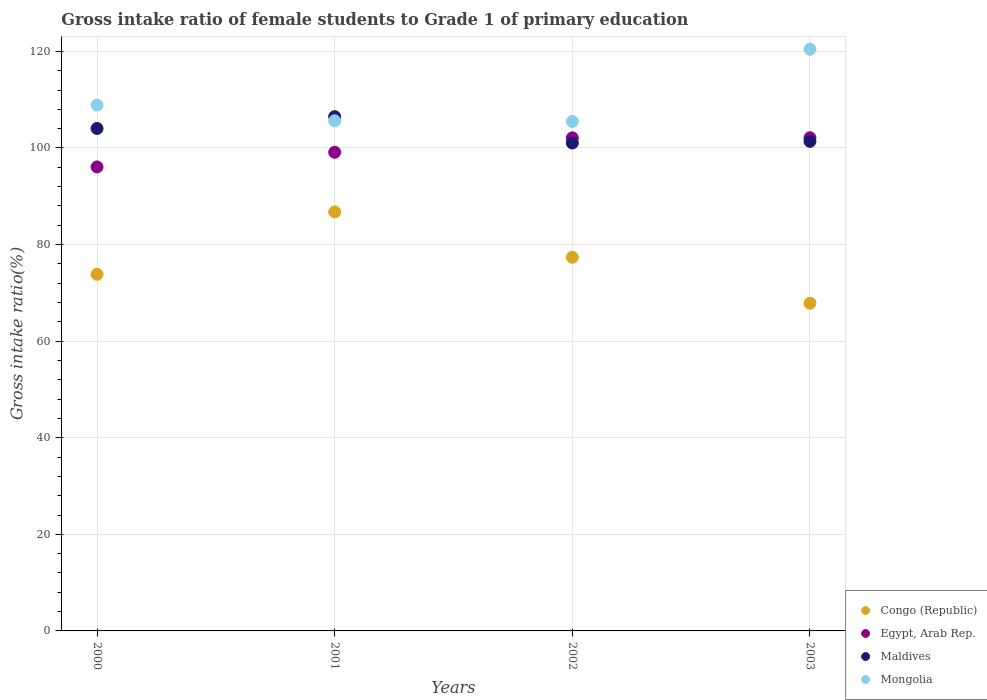How many different coloured dotlines are there?
Your response must be concise. 4. What is the gross intake ratio in Congo (Republic) in 2002?
Your response must be concise. 77.37. Across all years, what is the maximum gross intake ratio in Congo (Republic)?
Offer a terse response. 86.76. Across all years, what is the minimum gross intake ratio in Maldives?
Provide a succinct answer. 101.03. In which year was the gross intake ratio in Egypt, Arab Rep. maximum?
Your answer should be compact. 2003. What is the total gross intake ratio in Maldives in the graph?
Offer a very short reply. 412.91. What is the difference between the gross intake ratio in Maldives in 2001 and that in 2003?
Offer a terse response. 5.12. What is the difference between the gross intake ratio in Mongolia in 2002 and the gross intake ratio in Egypt, Arab Rep. in 2000?
Make the answer very short. 9.41. What is the average gross intake ratio in Congo (Republic) per year?
Make the answer very short. 76.45. In the year 2003, what is the difference between the gross intake ratio in Maldives and gross intake ratio in Mongolia?
Give a very brief answer. -19.07. What is the ratio of the gross intake ratio in Egypt, Arab Rep. in 2000 to that in 2003?
Your answer should be compact. 0.94. Is the difference between the gross intake ratio in Maldives in 2001 and 2002 greater than the difference between the gross intake ratio in Mongolia in 2001 and 2002?
Give a very brief answer. Yes. What is the difference between the highest and the second highest gross intake ratio in Mongolia?
Offer a very short reply. 11.55. What is the difference between the highest and the lowest gross intake ratio in Mongolia?
Offer a very short reply. 14.95. Is it the case that in every year, the sum of the gross intake ratio in Mongolia and gross intake ratio in Maldives  is greater than the gross intake ratio in Congo (Republic)?
Keep it short and to the point. Yes. Is the gross intake ratio in Mongolia strictly greater than the gross intake ratio in Congo (Republic) over the years?
Your answer should be compact. Yes. How many dotlines are there?
Your response must be concise. 4. What is the difference between two consecutive major ticks on the Y-axis?
Offer a terse response. 20. Does the graph contain any zero values?
Ensure brevity in your answer.  No. How are the legend labels stacked?
Make the answer very short. Vertical. What is the title of the graph?
Your response must be concise. Gross intake ratio of female students to Grade 1 of primary education. Does "St. Kitts and Nevis" appear as one of the legend labels in the graph?
Offer a terse response. No. What is the label or title of the X-axis?
Offer a very short reply. Years. What is the label or title of the Y-axis?
Offer a very short reply. Gross intake ratio(%). What is the Gross intake ratio(%) of Congo (Republic) in 2000?
Give a very brief answer. 73.83. What is the Gross intake ratio(%) in Egypt, Arab Rep. in 2000?
Provide a succinct answer. 96.07. What is the Gross intake ratio(%) of Maldives in 2000?
Your response must be concise. 104.04. What is the Gross intake ratio(%) in Mongolia in 2000?
Offer a terse response. 108.89. What is the Gross intake ratio(%) in Congo (Republic) in 2001?
Your answer should be compact. 86.76. What is the Gross intake ratio(%) in Egypt, Arab Rep. in 2001?
Provide a short and direct response. 99.11. What is the Gross intake ratio(%) in Maldives in 2001?
Your answer should be very brief. 106.48. What is the Gross intake ratio(%) of Mongolia in 2001?
Provide a succinct answer. 105.63. What is the Gross intake ratio(%) in Congo (Republic) in 2002?
Provide a succinct answer. 77.37. What is the Gross intake ratio(%) of Egypt, Arab Rep. in 2002?
Give a very brief answer. 102.1. What is the Gross intake ratio(%) in Maldives in 2002?
Your answer should be compact. 101.03. What is the Gross intake ratio(%) in Mongolia in 2002?
Make the answer very short. 105.49. What is the Gross intake ratio(%) in Congo (Republic) in 2003?
Offer a very short reply. 67.85. What is the Gross intake ratio(%) in Egypt, Arab Rep. in 2003?
Give a very brief answer. 102.12. What is the Gross intake ratio(%) of Maldives in 2003?
Ensure brevity in your answer.  101.36. What is the Gross intake ratio(%) of Mongolia in 2003?
Offer a terse response. 120.43. Across all years, what is the maximum Gross intake ratio(%) in Congo (Republic)?
Your answer should be very brief. 86.76. Across all years, what is the maximum Gross intake ratio(%) in Egypt, Arab Rep.?
Keep it short and to the point. 102.12. Across all years, what is the maximum Gross intake ratio(%) of Maldives?
Your answer should be compact. 106.48. Across all years, what is the maximum Gross intake ratio(%) of Mongolia?
Make the answer very short. 120.43. Across all years, what is the minimum Gross intake ratio(%) in Congo (Republic)?
Provide a succinct answer. 67.85. Across all years, what is the minimum Gross intake ratio(%) of Egypt, Arab Rep.?
Provide a short and direct response. 96.07. Across all years, what is the minimum Gross intake ratio(%) in Maldives?
Your answer should be compact. 101.03. Across all years, what is the minimum Gross intake ratio(%) of Mongolia?
Offer a very short reply. 105.49. What is the total Gross intake ratio(%) of Congo (Republic) in the graph?
Make the answer very short. 305.82. What is the total Gross intake ratio(%) in Egypt, Arab Rep. in the graph?
Your response must be concise. 399.41. What is the total Gross intake ratio(%) of Maldives in the graph?
Provide a succinct answer. 412.91. What is the total Gross intake ratio(%) of Mongolia in the graph?
Offer a terse response. 440.44. What is the difference between the Gross intake ratio(%) in Congo (Republic) in 2000 and that in 2001?
Your response must be concise. -12.93. What is the difference between the Gross intake ratio(%) of Egypt, Arab Rep. in 2000 and that in 2001?
Your response must be concise. -3.04. What is the difference between the Gross intake ratio(%) in Maldives in 2000 and that in 2001?
Offer a very short reply. -2.44. What is the difference between the Gross intake ratio(%) of Mongolia in 2000 and that in 2001?
Give a very brief answer. 3.26. What is the difference between the Gross intake ratio(%) in Congo (Republic) in 2000 and that in 2002?
Make the answer very short. -3.53. What is the difference between the Gross intake ratio(%) in Egypt, Arab Rep. in 2000 and that in 2002?
Offer a terse response. -6.03. What is the difference between the Gross intake ratio(%) in Maldives in 2000 and that in 2002?
Ensure brevity in your answer.  3.01. What is the difference between the Gross intake ratio(%) of Mongolia in 2000 and that in 2002?
Provide a succinct answer. 3.4. What is the difference between the Gross intake ratio(%) in Congo (Republic) in 2000 and that in 2003?
Your answer should be compact. 5.98. What is the difference between the Gross intake ratio(%) of Egypt, Arab Rep. in 2000 and that in 2003?
Provide a succinct answer. -6.05. What is the difference between the Gross intake ratio(%) of Maldives in 2000 and that in 2003?
Make the answer very short. 2.67. What is the difference between the Gross intake ratio(%) in Mongolia in 2000 and that in 2003?
Your answer should be compact. -11.55. What is the difference between the Gross intake ratio(%) in Congo (Republic) in 2001 and that in 2002?
Offer a terse response. 9.4. What is the difference between the Gross intake ratio(%) of Egypt, Arab Rep. in 2001 and that in 2002?
Offer a terse response. -2.99. What is the difference between the Gross intake ratio(%) in Maldives in 2001 and that in 2002?
Make the answer very short. 5.45. What is the difference between the Gross intake ratio(%) of Mongolia in 2001 and that in 2002?
Your answer should be compact. 0.14. What is the difference between the Gross intake ratio(%) of Congo (Republic) in 2001 and that in 2003?
Your response must be concise. 18.91. What is the difference between the Gross intake ratio(%) of Egypt, Arab Rep. in 2001 and that in 2003?
Your answer should be compact. -3.01. What is the difference between the Gross intake ratio(%) in Maldives in 2001 and that in 2003?
Provide a succinct answer. 5.12. What is the difference between the Gross intake ratio(%) in Mongolia in 2001 and that in 2003?
Ensure brevity in your answer.  -14.81. What is the difference between the Gross intake ratio(%) in Congo (Republic) in 2002 and that in 2003?
Your answer should be compact. 9.51. What is the difference between the Gross intake ratio(%) of Egypt, Arab Rep. in 2002 and that in 2003?
Make the answer very short. -0.02. What is the difference between the Gross intake ratio(%) in Maldives in 2002 and that in 2003?
Keep it short and to the point. -0.34. What is the difference between the Gross intake ratio(%) in Mongolia in 2002 and that in 2003?
Your response must be concise. -14.95. What is the difference between the Gross intake ratio(%) in Congo (Republic) in 2000 and the Gross intake ratio(%) in Egypt, Arab Rep. in 2001?
Provide a succinct answer. -25.28. What is the difference between the Gross intake ratio(%) of Congo (Republic) in 2000 and the Gross intake ratio(%) of Maldives in 2001?
Keep it short and to the point. -32.65. What is the difference between the Gross intake ratio(%) in Congo (Republic) in 2000 and the Gross intake ratio(%) in Mongolia in 2001?
Give a very brief answer. -31.79. What is the difference between the Gross intake ratio(%) in Egypt, Arab Rep. in 2000 and the Gross intake ratio(%) in Maldives in 2001?
Provide a succinct answer. -10.41. What is the difference between the Gross intake ratio(%) of Egypt, Arab Rep. in 2000 and the Gross intake ratio(%) of Mongolia in 2001?
Offer a very short reply. -9.56. What is the difference between the Gross intake ratio(%) of Maldives in 2000 and the Gross intake ratio(%) of Mongolia in 2001?
Ensure brevity in your answer.  -1.59. What is the difference between the Gross intake ratio(%) in Congo (Republic) in 2000 and the Gross intake ratio(%) in Egypt, Arab Rep. in 2002?
Keep it short and to the point. -28.26. What is the difference between the Gross intake ratio(%) of Congo (Republic) in 2000 and the Gross intake ratio(%) of Maldives in 2002?
Provide a short and direct response. -27.19. What is the difference between the Gross intake ratio(%) in Congo (Republic) in 2000 and the Gross intake ratio(%) in Mongolia in 2002?
Ensure brevity in your answer.  -31.65. What is the difference between the Gross intake ratio(%) in Egypt, Arab Rep. in 2000 and the Gross intake ratio(%) in Maldives in 2002?
Keep it short and to the point. -4.95. What is the difference between the Gross intake ratio(%) in Egypt, Arab Rep. in 2000 and the Gross intake ratio(%) in Mongolia in 2002?
Offer a very short reply. -9.41. What is the difference between the Gross intake ratio(%) of Maldives in 2000 and the Gross intake ratio(%) of Mongolia in 2002?
Offer a terse response. -1.45. What is the difference between the Gross intake ratio(%) in Congo (Republic) in 2000 and the Gross intake ratio(%) in Egypt, Arab Rep. in 2003?
Ensure brevity in your answer.  -28.29. What is the difference between the Gross intake ratio(%) in Congo (Republic) in 2000 and the Gross intake ratio(%) in Maldives in 2003?
Your answer should be very brief. -27.53. What is the difference between the Gross intake ratio(%) in Congo (Republic) in 2000 and the Gross intake ratio(%) in Mongolia in 2003?
Make the answer very short. -46.6. What is the difference between the Gross intake ratio(%) in Egypt, Arab Rep. in 2000 and the Gross intake ratio(%) in Maldives in 2003?
Keep it short and to the point. -5.29. What is the difference between the Gross intake ratio(%) in Egypt, Arab Rep. in 2000 and the Gross intake ratio(%) in Mongolia in 2003?
Make the answer very short. -24.36. What is the difference between the Gross intake ratio(%) in Maldives in 2000 and the Gross intake ratio(%) in Mongolia in 2003?
Provide a short and direct response. -16.4. What is the difference between the Gross intake ratio(%) in Congo (Republic) in 2001 and the Gross intake ratio(%) in Egypt, Arab Rep. in 2002?
Your answer should be compact. -15.34. What is the difference between the Gross intake ratio(%) of Congo (Republic) in 2001 and the Gross intake ratio(%) of Maldives in 2002?
Make the answer very short. -14.27. What is the difference between the Gross intake ratio(%) of Congo (Republic) in 2001 and the Gross intake ratio(%) of Mongolia in 2002?
Keep it short and to the point. -18.72. What is the difference between the Gross intake ratio(%) in Egypt, Arab Rep. in 2001 and the Gross intake ratio(%) in Maldives in 2002?
Give a very brief answer. -1.92. What is the difference between the Gross intake ratio(%) of Egypt, Arab Rep. in 2001 and the Gross intake ratio(%) of Mongolia in 2002?
Offer a very short reply. -6.37. What is the difference between the Gross intake ratio(%) of Maldives in 2001 and the Gross intake ratio(%) of Mongolia in 2002?
Provide a succinct answer. 0.99. What is the difference between the Gross intake ratio(%) of Congo (Republic) in 2001 and the Gross intake ratio(%) of Egypt, Arab Rep. in 2003?
Offer a very short reply. -15.36. What is the difference between the Gross intake ratio(%) in Congo (Republic) in 2001 and the Gross intake ratio(%) in Maldives in 2003?
Offer a very short reply. -14.6. What is the difference between the Gross intake ratio(%) in Congo (Republic) in 2001 and the Gross intake ratio(%) in Mongolia in 2003?
Your answer should be compact. -33.67. What is the difference between the Gross intake ratio(%) in Egypt, Arab Rep. in 2001 and the Gross intake ratio(%) in Maldives in 2003?
Your response must be concise. -2.25. What is the difference between the Gross intake ratio(%) of Egypt, Arab Rep. in 2001 and the Gross intake ratio(%) of Mongolia in 2003?
Your answer should be compact. -21.32. What is the difference between the Gross intake ratio(%) in Maldives in 2001 and the Gross intake ratio(%) in Mongolia in 2003?
Offer a very short reply. -13.95. What is the difference between the Gross intake ratio(%) of Congo (Republic) in 2002 and the Gross intake ratio(%) of Egypt, Arab Rep. in 2003?
Keep it short and to the point. -24.76. What is the difference between the Gross intake ratio(%) of Congo (Republic) in 2002 and the Gross intake ratio(%) of Maldives in 2003?
Make the answer very short. -24. What is the difference between the Gross intake ratio(%) of Congo (Republic) in 2002 and the Gross intake ratio(%) of Mongolia in 2003?
Give a very brief answer. -43.07. What is the difference between the Gross intake ratio(%) of Egypt, Arab Rep. in 2002 and the Gross intake ratio(%) of Maldives in 2003?
Provide a succinct answer. 0.73. What is the difference between the Gross intake ratio(%) in Egypt, Arab Rep. in 2002 and the Gross intake ratio(%) in Mongolia in 2003?
Your response must be concise. -18.34. What is the difference between the Gross intake ratio(%) in Maldives in 2002 and the Gross intake ratio(%) in Mongolia in 2003?
Offer a terse response. -19.41. What is the average Gross intake ratio(%) in Congo (Republic) per year?
Offer a very short reply. 76.45. What is the average Gross intake ratio(%) in Egypt, Arab Rep. per year?
Offer a terse response. 99.85. What is the average Gross intake ratio(%) in Maldives per year?
Offer a terse response. 103.23. What is the average Gross intake ratio(%) in Mongolia per year?
Make the answer very short. 110.11. In the year 2000, what is the difference between the Gross intake ratio(%) in Congo (Republic) and Gross intake ratio(%) in Egypt, Arab Rep.?
Provide a succinct answer. -22.24. In the year 2000, what is the difference between the Gross intake ratio(%) in Congo (Republic) and Gross intake ratio(%) in Maldives?
Your response must be concise. -30.2. In the year 2000, what is the difference between the Gross intake ratio(%) of Congo (Republic) and Gross intake ratio(%) of Mongolia?
Make the answer very short. -35.05. In the year 2000, what is the difference between the Gross intake ratio(%) of Egypt, Arab Rep. and Gross intake ratio(%) of Maldives?
Provide a succinct answer. -7.97. In the year 2000, what is the difference between the Gross intake ratio(%) in Egypt, Arab Rep. and Gross intake ratio(%) in Mongolia?
Keep it short and to the point. -12.81. In the year 2000, what is the difference between the Gross intake ratio(%) of Maldives and Gross intake ratio(%) of Mongolia?
Your answer should be very brief. -4.85. In the year 2001, what is the difference between the Gross intake ratio(%) of Congo (Republic) and Gross intake ratio(%) of Egypt, Arab Rep.?
Your answer should be compact. -12.35. In the year 2001, what is the difference between the Gross intake ratio(%) in Congo (Republic) and Gross intake ratio(%) in Maldives?
Offer a terse response. -19.72. In the year 2001, what is the difference between the Gross intake ratio(%) in Congo (Republic) and Gross intake ratio(%) in Mongolia?
Provide a short and direct response. -18.87. In the year 2001, what is the difference between the Gross intake ratio(%) in Egypt, Arab Rep. and Gross intake ratio(%) in Maldives?
Offer a terse response. -7.37. In the year 2001, what is the difference between the Gross intake ratio(%) of Egypt, Arab Rep. and Gross intake ratio(%) of Mongolia?
Provide a short and direct response. -6.52. In the year 2001, what is the difference between the Gross intake ratio(%) in Maldives and Gross intake ratio(%) in Mongolia?
Offer a terse response. 0.85. In the year 2002, what is the difference between the Gross intake ratio(%) of Congo (Republic) and Gross intake ratio(%) of Egypt, Arab Rep.?
Your answer should be compact. -24.73. In the year 2002, what is the difference between the Gross intake ratio(%) in Congo (Republic) and Gross intake ratio(%) in Maldives?
Offer a very short reply. -23.66. In the year 2002, what is the difference between the Gross intake ratio(%) in Congo (Republic) and Gross intake ratio(%) in Mongolia?
Offer a very short reply. -28.12. In the year 2002, what is the difference between the Gross intake ratio(%) in Egypt, Arab Rep. and Gross intake ratio(%) in Maldives?
Your answer should be compact. 1.07. In the year 2002, what is the difference between the Gross intake ratio(%) of Egypt, Arab Rep. and Gross intake ratio(%) of Mongolia?
Provide a short and direct response. -3.39. In the year 2002, what is the difference between the Gross intake ratio(%) in Maldives and Gross intake ratio(%) in Mongolia?
Your answer should be very brief. -4.46. In the year 2003, what is the difference between the Gross intake ratio(%) in Congo (Republic) and Gross intake ratio(%) in Egypt, Arab Rep.?
Make the answer very short. -34.27. In the year 2003, what is the difference between the Gross intake ratio(%) of Congo (Republic) and Gross intake ratio(%) of Maldives?
Provide a short and direct response. -33.51. In the year 2003, what is the difference between the Gross intake ratio(%) of Congo (Republic) and Gross intake ratio(%) of Mongolia?
Your response must be concise. -52.58. In the year 2003, what is the difference between the Gross intake ratio(%) in Egypt, Arab Rep. and Gross intake ratio(%) in Maldives?
Keep it short and to the point. 0.76. In the year 2003, what is the difference between the Gross intake ratio(%) in Egypt, Arab Rep. and Gross intake ratio(%) in Mongolia?
Make the answer very short. -18.31. In the year 2003, what is the difference between the Gross intake ratio(%) of Maldives and Gross intake ratio(%) of Mongolia?
Your answer should be compact. -19.07. What is the ratio of the Gross intake ratio(%) in Congo (Republic) in 2000 to that in 2001?
Provide a short and direct response. 0.85. What is the ratio of the Gross intake ratio(%) of Egypt, Arab Rep. in 2000 to that in 2001?
Provide a short and direct response. 0.97. What is the ratio of the Gross intake ratio(%) of Maldives in 2000 to that in 2001?
Make the answer very short. 0.98. What is the ratio of the Gross intake ratio(%) of Mongolia in 2000 to that in 2001?
Your answer should be very brief. 1.03. What is the ratio of the Gross intake ratio(%) in Congo (Republic) in 2000 to that in 2002?
Provide a short and direct response. 0.95. What is the ratio of the Gross intake ratio(%) of Egypt, Arab Rep. in 2000 to that in 2002?
Provide a short and direct response. 0.94. What is the ratio of the Gross intake ratio(%) of Maldives in 2000 to that in 2002?
Give a very brief answer. 1.03. What is the ratio of the Gross intake ratio(%) in Mongolia in 2000 to that in 2002?
Give a very brief answer. 1.03. What is the ratio of the Gross intake ratio(%) of Congo (Republic) in 2000 to that in 2003?
Ensure brevity in your answer.  1.09. What is the ratio of the Gross intake ratio(%) of Egypt, Arab Rep. in 2000 to that in 2003?
Your answer should be compact. 0.94. What is the ratio of the Gross intake ratio(%) of Maldives in 2000 to that in 2003?
Offer a terse response. 1.03. What is the ratio of the Gross intake ratio(%) of Mongolia in 2000 to that in 2003?
Offer a terse response. 0.9. What is the ratio of the Gross intake ratio(%) in Congo (Republic) in 2001 to that in 2002?
Your answer should be very brief. 1.12. What is the ratio of the Gross intake ratio(%) in Egypt, Arab Rep. in 2001 to that in 2002?
Your answer should be compact. 0.97. What is the ratio of the Gross intake ratio(%) of Maldives in 2001 to that in 2002?
Provide a succinct answer. 1.05. What is the ratio of the Gross intake ratio(%) in Congo (Republic) in 2001 to that in 2003?
Keep it short and to the point. 1.28. What is the ratio of the Gross intake ratio(%) of Egypt, Arab Rep. in 2001 to that in 2003?
Offer a very short reply. 0.97. What is the ratio of the Gross intake ratio(%) in Maldives in 2001 to that in 2003?
Ensure brevity in your answer.  1.05. What is the ratio of the Gross intake ratio(%) of Mongolia in 2001 to that in 2003?
Offer a very short reply. 0.88. What is the ratio of the Gross intake ratio(%) in Congo (Republic) in 2002 to that in 2003?
Your answer should be very brief. 1.14. What is the ratio of the Gross intake ratio(%) of Mongolia in 2002 to that in 2003?
Provide a succinct answer. 0.88. What is the difference between the highest and the second highest Gross intake ratio(%) in Congo (Republic)?
Your answer should be very brief. 9.4. What is the difference between the highest and the second highest Gross intake ratio(%) of Egypt, Arab Rep.?
Keep it short and to the point. 0.02. What is the difference between the highest and the second highest Gross intake ratio(%) of Maldives?
Your response must be concise. 2.44. What is the difference between the highest and the second highest Gross intake ratio(%) of Mongolia?
Provide a succinct answer. 11.55. What is the difference between the highest and the lowest Gross intake ratio(%) in Congo (Republic)?
Provide a short and direct response. 18.91. What is the difference between the highest and the lowest Gross intake ratio(%) in Egypt, Arab Rep.?
Keep it short and to the point. 6.05. What is the difference between the highest and the lowest Gross intake ratio(%) in Maldives?
Your answer should be compact. 5.45. What is the difference between the highest and the lowest Gross intake ratio(%) of Mongolia?
Offer a very short reply. 14.95. 